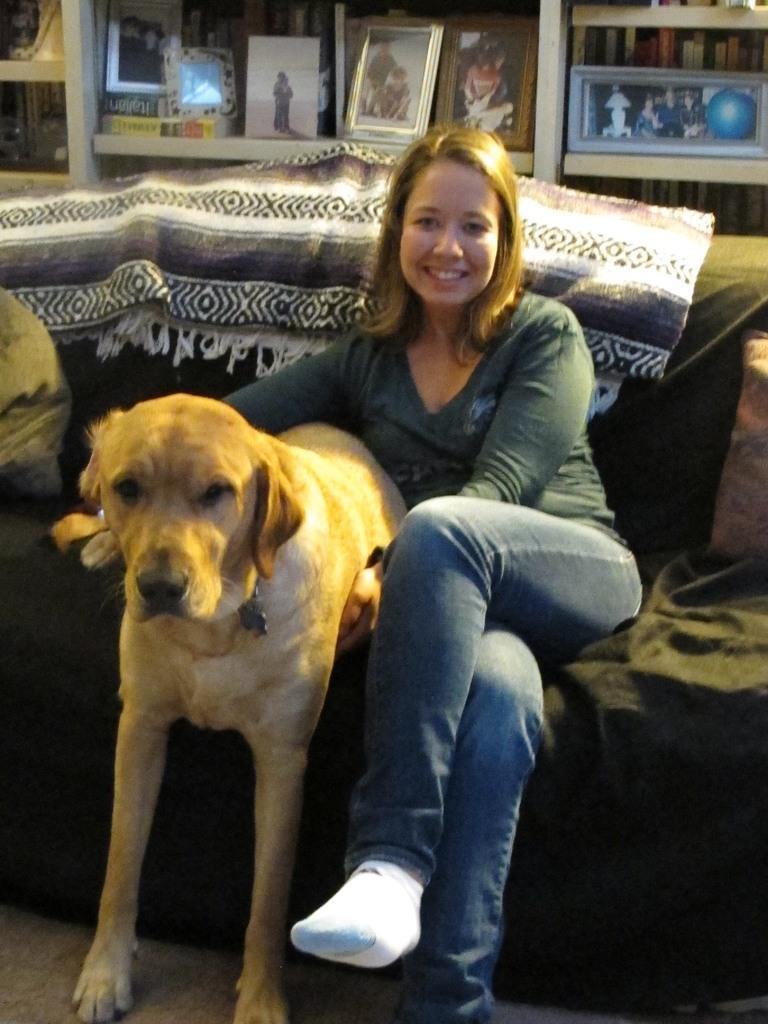Could you give a brief overview of what you see in this image? This picture is of inside the room. In the center there is a woman wearing green color t-shirt, smiling and sitting on a couch, beside there is a dog standing on the floor. In the background we can see the cabinet containing photo frames and a wall. 